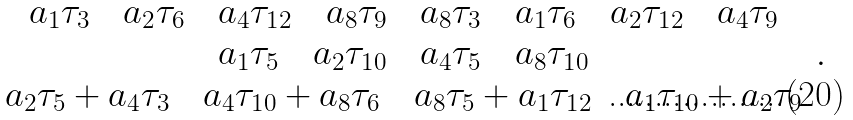<formula> <loc_0><loc_0><loc_500><loc_500>\begin{array} { c } a _ { 1 } \tau _ { 3 } \quad a _ { 2 } \tau _ { 6 } \quad a _ { 4 } \tau _ { 1 2 } \quad a _ { 8 } \tau _ { 9 } \quad a _ { 8 } \tau _ { 3 } \quad a _ { 1 } \tau _ { 6 } \quad a _ { 2 } \tau _ { 1 2 } \quad a _ { 4 } \tau _ { 9 } \\ a _ { 1 } \tau _ { 5 } \quad a _ { 2 } \tau _ { 1 0 } \quad a _ { 4 } \tau _ { 5 } \quad a _ { 8 } \tau _ { 1 0 } \\ a _ { 2 } \tau _ { 5 } + a _ { 4 } \tau _ { 3 } \quad a _ { 4 } \tau _ { 1 0 } + a _ { 8 } \tau _ { 6 } \quad a _ { 8 } \tau _ { 5 } + a _ { 1 } \tau _ { 1 2 } \quad a _ { 1 } \tau _ { 1 0 } + a _ { 2 } \tau _ { 9 } \end{array} \, .</formula> 